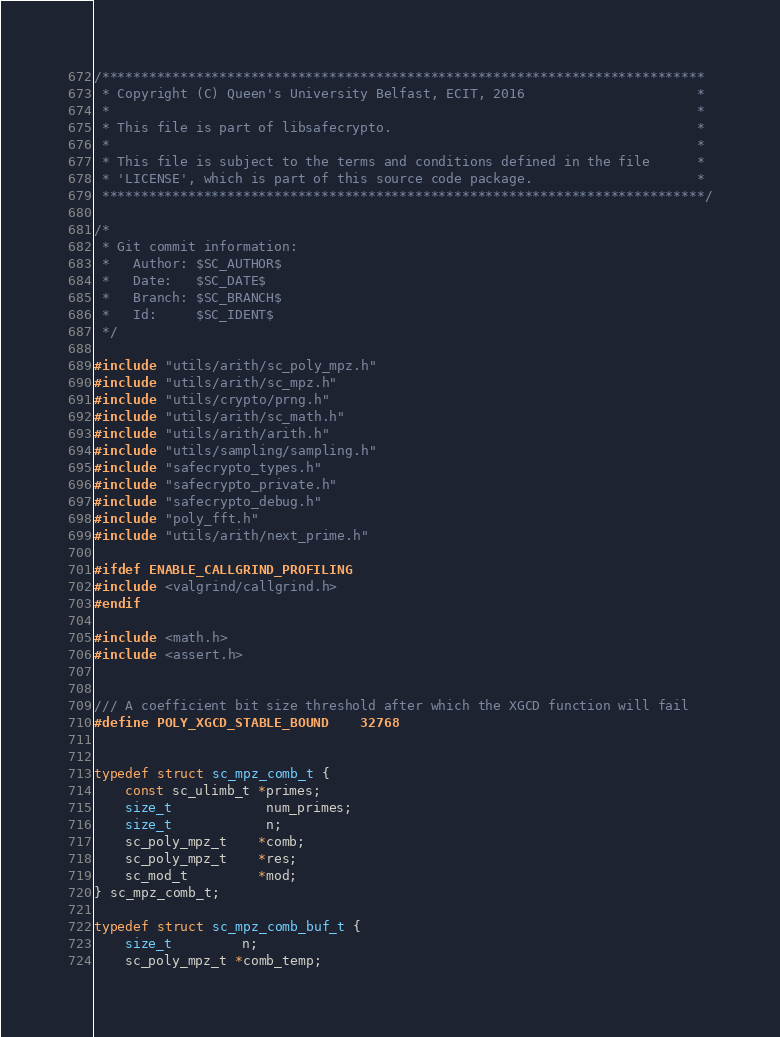Convert code to text. <code><loc_0><loc_0><loc_500><loc_500><_C_>/*****************************************************************************
 * Copyright (C) Queen's University Belfast, ECIT, 2016                      *
 *                                                                           *
 * This file is part of libsafecrypto.                                       *
 *                                                                           *
 * This file is subject to the terms and conditions defined in the file      *
 * 'LICENSE', which is part of this source code package.                     *
 *****************************************************************************/

/*
 * Git commit information:
 *   Author: $SC_AUTHOR$
 *   Date:   $SC_DATE$
 *   Branch: $SC_BRANCH$
 *   Id:     $SC_IDENT$
 */

#include "utils/arith/sc_poly_mpz.h"
#include "utils/arith/sc_mpz.h"
#include "utils/crypto/prng.h"
#include "utils/arith/sc_math.h"
#include "utils/arith/arith.h"
#include "utils/sampling/sampling.h"
#include "safecrypto_types.h"
#include "safecrypto_private.h"
#include "safecrypto_debug.h"
#include "poly_fft.h"
#include "utils/arith/next_prime.h"

#ifdef ENABLE_CALLGRIND_PROFILING
#include <valgrind/callgrind.h>
#endif

#include <math.h>
#include <assert.h>


/// A coefficient bit size threshold after which the XGCD function will fail
#define POLY_XGCD_STABLE_BOUND    32768


typedef struct sc_mpz_comb_t {
    const sc_ulimb_t *primes;
    size_t            num_primes;
    size_t            n;
    sc_poly_mpz_t    *comb;
    sc_poly_mpz_t    *res;
    sc_mod_t         *mod;
} sc_mpz_comb_t;

typedef struct sc_mpz_comb_buf_t {
    size_t         n;
    sc_poly_mpz_t *comb_temp;</code> 